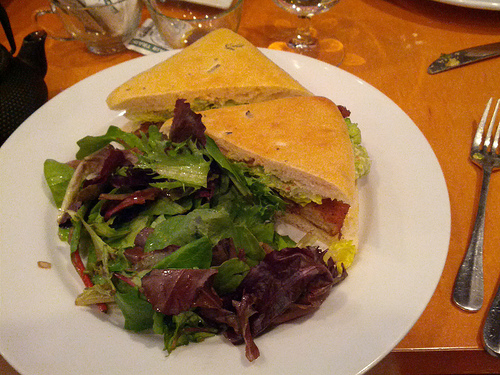What type of sandwich is pictured, and what ingredients can you identify? This appears to be a classic ham and cheese sandwich. It includes ham, cheese, lettuce, and tomatoes, neatly stacked between slices of lightly toasted bread. 